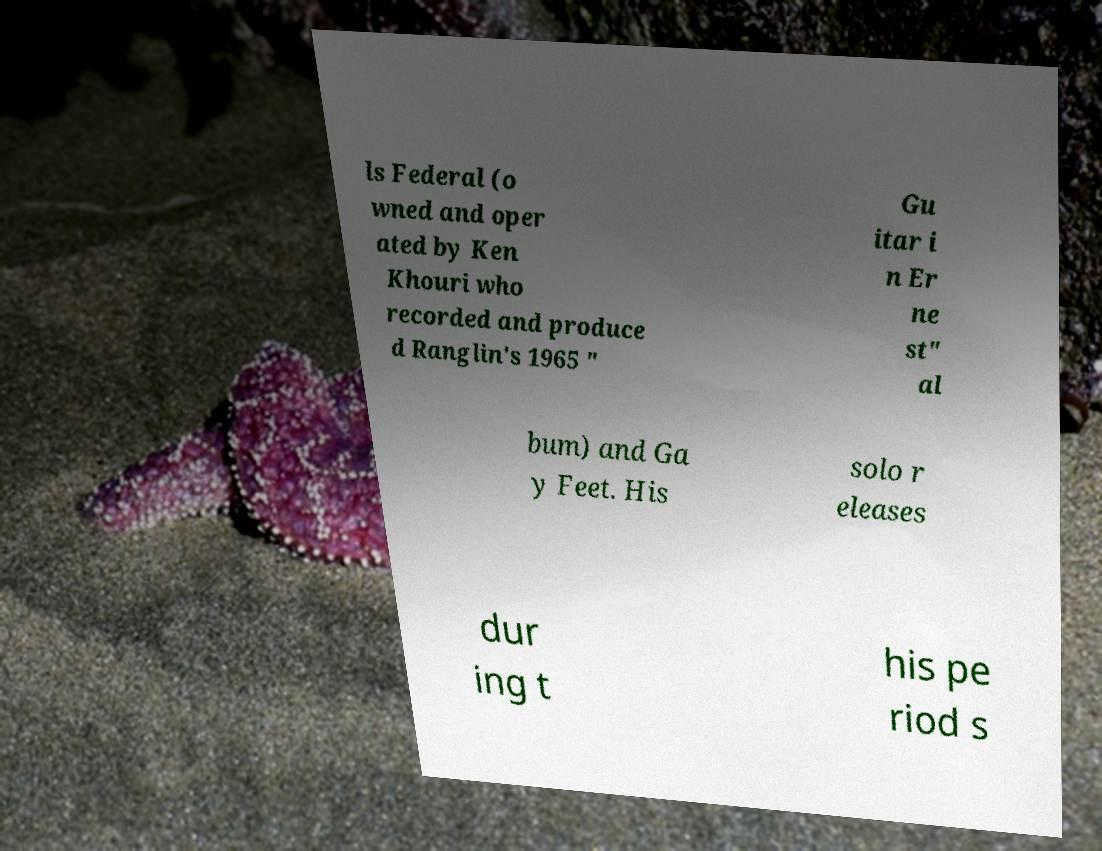Please read and relay the text visible in this image. What does it say? ls Federal (o wned and oper ated by Ken Khouri who recorded and produce d Ranglin's 1965 " Gu itar i n Er ne st" al bum) and Ga y Feet. His solo r eleases dur ing t his pe riod s 